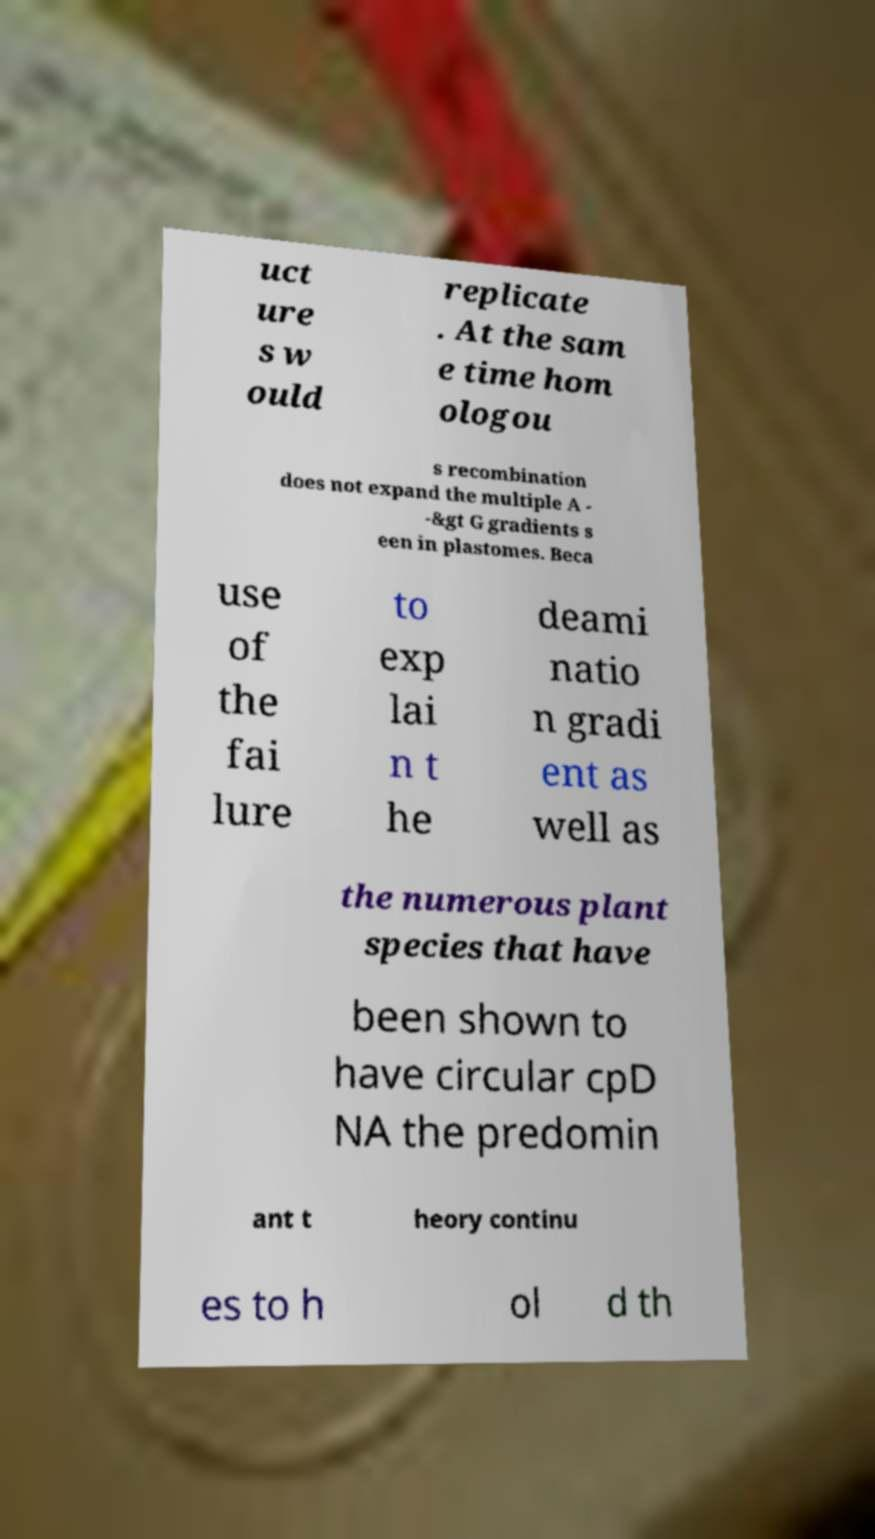For documentation purposes, I need the text within this image transcribed. Could you provide that? uct ure s w ould replicate . At the sam e time hom ologou s recombination does not expand the multiple A - -&gt G gradients s een in plastomes. Beca use of the fai lure to exp lai n t he deami natio n gradi ent as well as the numerous plant species that have been shown to have circular cpD NA the predomin ant t heory continu es to h ol d th 